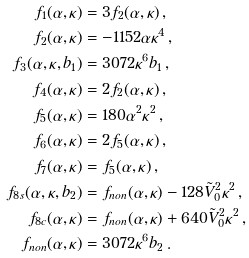Convert formula to latex. <formula><loc_0><loc_0><loc_500><loc_500>f _ { 1 } ( \alpha , \kappa ) & = 3 f _ { 2 } ( \alpha , \kappa ) \, , \\ f _ { 2 } ( \alpha , \kappa ) & = - 1 1 5 2 \alpha \kappa ^ { 4 } \, , \\ f _ { 3 } ( \alpha , \kappa , b _ { 1 } ) & = 3 0 7 2 \kappa ^ { 6 } b _ { 1 } \, , \\ f _ { 4 } ( \alpha , \kappa ) & = 2 f _ { 2 } ( \alpha , \kappa ) \, , \\ f _ { 5 } ( \alpha , \kappa ) & = 1 8 0 \alpha ^ { 2 } \kappa ^ { 2 } \, , \\ f _ { 6 } ( \alpha , \kappa ) & = 2 f _ { 5 } ( \alpha , \kappa ) \, , \\ f _ { 7 } ( \alpha , \kappa ) & = f _ { 5 } ( \alpha , \kappa ) \, , \\ f _ { 8 s } ( \alpha , \kappa , b _ { 2 } ) & = f _ { n o n } ( \alpha , \kappa ) - 1 2 8 \tilde { V } _ { 0 } ^ { 2 } \kappa ^ { 2 } \, , \\ f _ { 8 c } ( \alpha , \kappa ) & = f _ { n o n } ( \alpha , \kappa ) + 6 4 0 \tilde { V } _ { 0 } ^ { 2 } \kappa ^ { 2 } \, , \\ f _ { n o n } ( \alpha , \kappa ) & = 3 0 7 2 \kappa ^ { 6 } b _ { 2 } \, .</formula> 